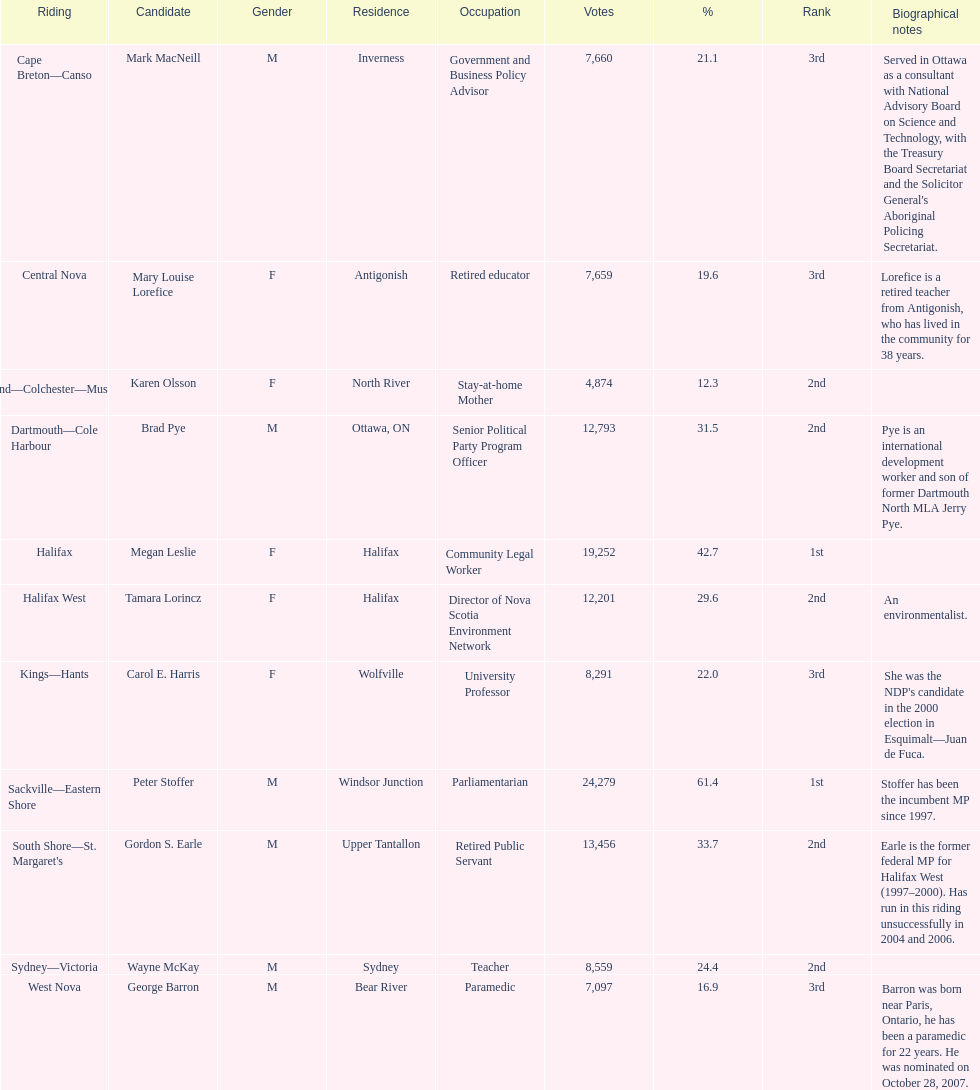How many applicants were from halifax? 2. 